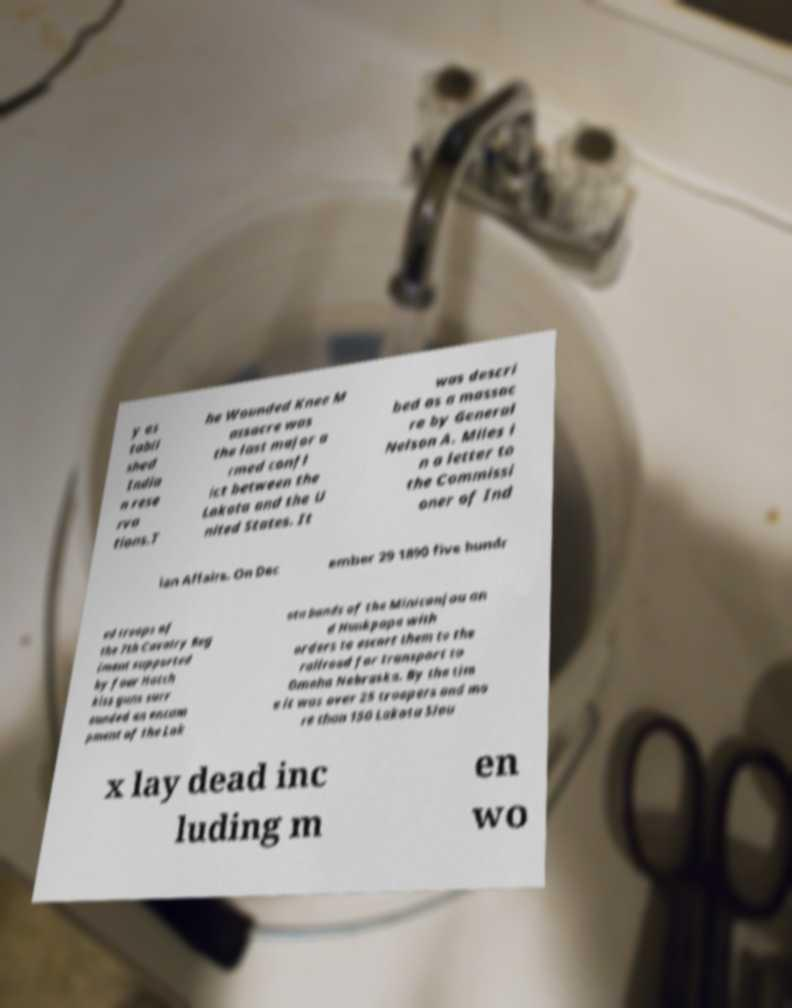Please read and relay the text visible in this image. What does it say? y es tabli shed India n rese rva tions.T he Wounded Knee M assacre was the last major a rmed confl ict between the Lakota and the U nited States. It was descri bed as a massac re by General Nelson A. Miles i n a letter to the Commissi oner of Ind ian Affairs. On Dec ember 29 1890 five hundr ed troops of the 7th Cavalry Reg iment supported by four Hotch kiss guns surr ounded an encam pment of the Lak ota bands of the Miniconjou an d Hunkpapa with orders to escort them to the railroad for transport to Omaha Nebraska. By the tim e it was over 25 troopers and mo re than 150 Lakota Siou x lay dead inc luding m en wo 